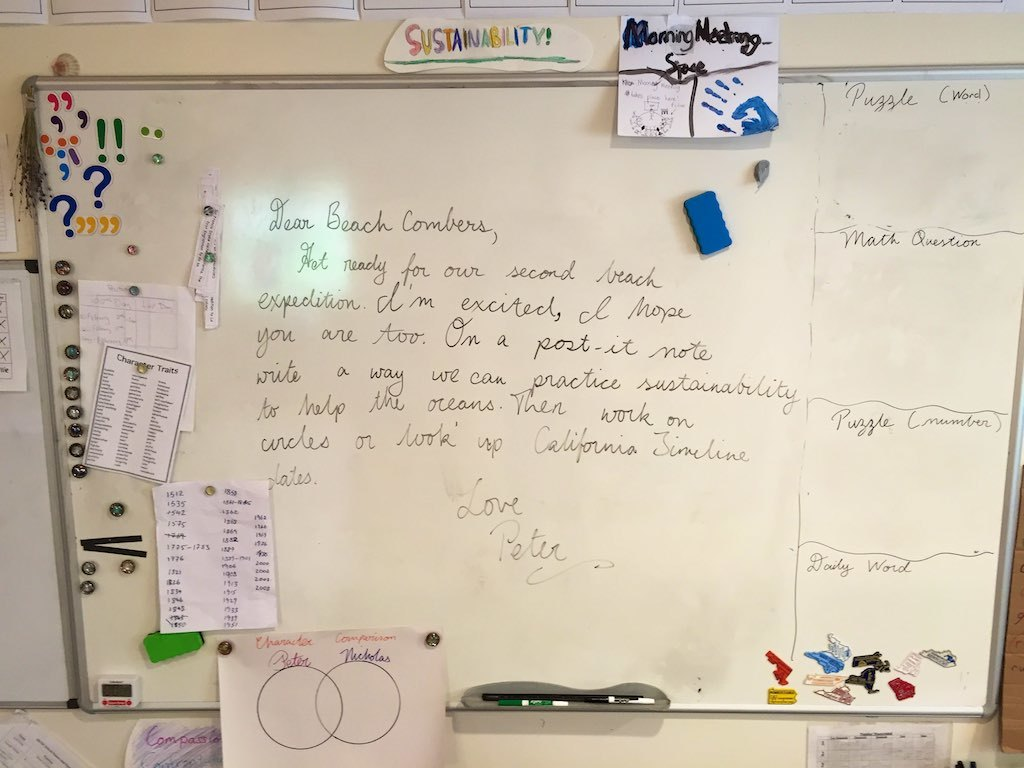What do the objects attached to the board tell us about the workplace culture? The variety of objects on the whiteboard, including colorful magnets, markers, and a hanging key, suggest a vibrant and open workplace culture. The presence of these items indicates a space that values creative expression and shared resources. The key may symbolize trust and responsibility given to team members, reinforcing a culture of mutual respect and accountability. 